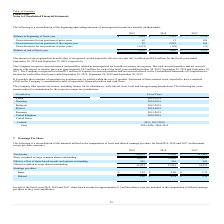From Plexus's financial document, Which years does the table provide information for the beginning and ending amounts of unrecognized income tax benefits? The document contains multiple relevant values: 2019, 2018, 2017. From the document: "2019 2018 2017 2019 2018 2017 2019 2018 2017..." Also, What was the amount of Gross increases for tax positions of prior years in 2019? According to the financial document, 62 (in thousands). The relevant text states: "Gross increases for tax positions of prior years 62 21 184..." Also, What was the Balance at end of fiscal year in 2017? According to the financial document, 3,115 (in thousands). The relevant text states: "Balance at beginning of fiscal year $ 5,841 $ 3,115 $ 2,799..." Also, How many years did Gross increases for tax positions of the current year exceed $1,000 thousand? Based on the analysis, there are 1 instances. The counting process: 2018. Also, can you calculate: What was the change in the Gross increases for tax positions of prior years between 2018 and 2019? Based on the calculation: 62-21, the result is 41. This is based on the information: "Gross increases for tax positions of prior years 62 21 184 oss increases for tax positions of prior years 62 21 184..." The key data points involved are: 21, 62. Also, can you calculate: What was the percentage change in the balance at end of fiscal year between 2018 and 2019? To answer this question, I need to perform calculations using the financial data. The calculation is: (2,270-5,841)/5,841, which equals -61.14 (percentage). This is based on the information: "Balance at end of fiscal year $ 2,270 $ 5,841 $ 3,115 Balance at end of fiscal year $ 2,270 $ 5,841 $ 3,115..." The key data points involved are: 2,270, 5,841. 